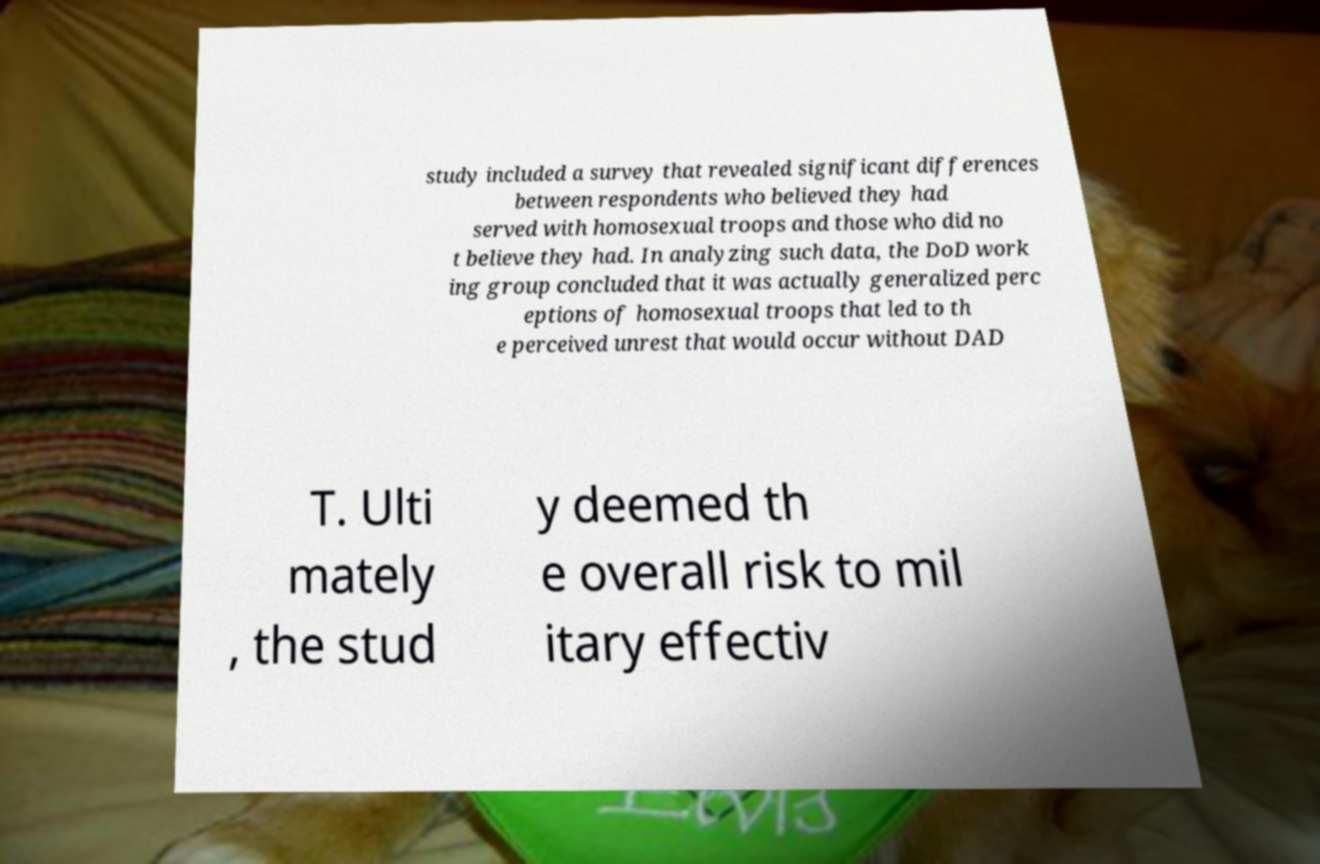There's text embedded in this image that I need extracted. Can you transcribe it verbatim? study included a survey that revealed significant differences between respondents who believed they had served with homosexual troops and those who did no t believe they had. In analyzing such data, the DoD work ing group concluded that it was actually generalized perc eptions of homosexual troops that led to th e perceived unrest that would occur without DAD T. Ulti mately , the stud y deemed th e overall risk to mil itary effectiv 